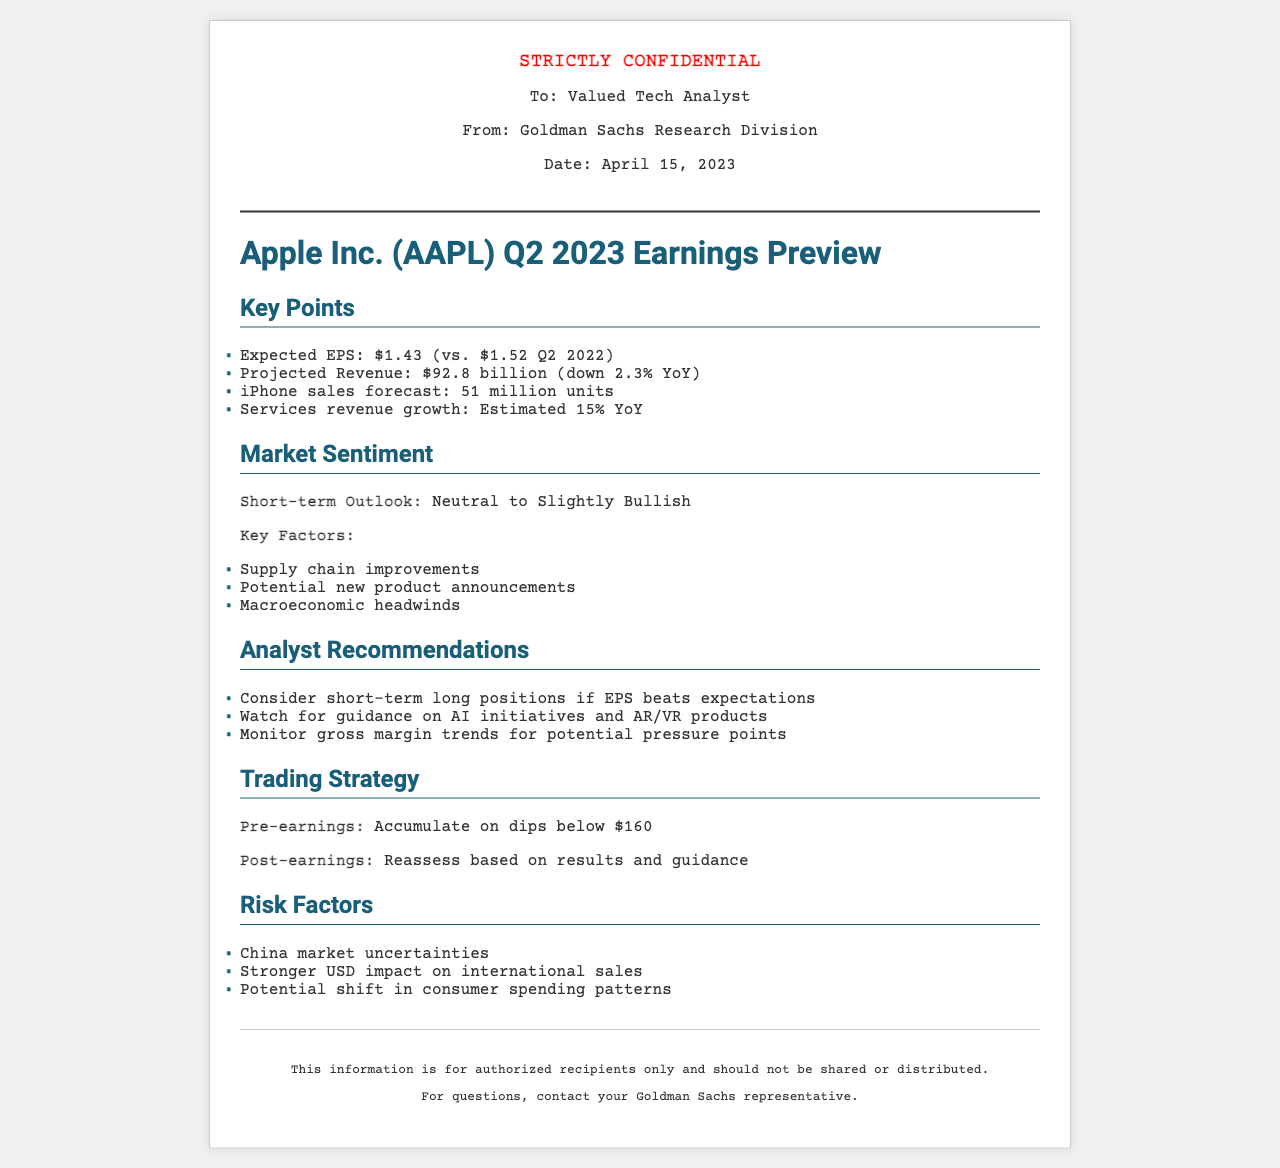What is the expected EPS for Q2 2023? The expected EPS for Q2 2023 is stated in the document as $1.43.
Answer: $1.43 What is the projected revenue for Apple Inc. in Q2 2023? The projected revenue mentioned in the document is $92.8 billion.
Answer: $92.8 billion How many iPhone units are forecasted to be sold? The number of iPhone units forecasted in the document is 51 million.
Answer: 51 million What is the short-term outlook for market sentiment? The document describes the market sentiment outlook as Neutral to Slightly Bullish.
Answer: Neutral to Slightly Bullish What should be monitored for potential pressure points? The document advises to monitor gross margin trends for potential pressure points.
Answer: Gross margin trends What is the pre-earnings trading strategy suggested in the document? The pre-earnings trading strategy states to accumulate on dips below $160.
Answer: Accumulate on dips below $160 What is one of the risk factors mentioned related to the consumer market? The document notes potential shift in consumer spending patterns as a risk factor.
Answer: Shift in consumer spending patterns Which initiative should analysts watch for insights? The document suggests watching for guidance on AI initiatives and AR/VR products.
Answer: AI initiatives and AR/VR products What is the date of the earnings preview? The date of the earnings preview is clearly stated in the document as April 15, 2023.
Answer: April 15, 2023 